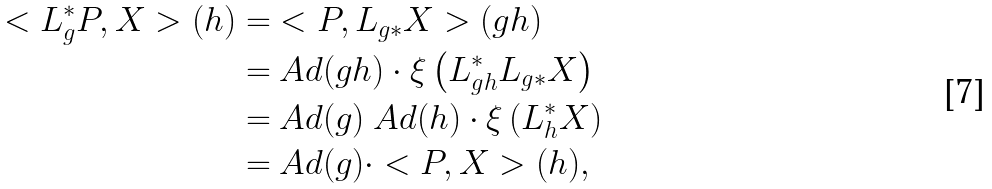Convert formula to latex. <formula><loc_0><loc_0><loc_500><loc_500>< L _ { g } ^ { * } P , X > ( h ) = & < P , L _ { g * } X > ( g h ) \\ = & \ A d ( g h ) \cdot \xi \left ( L _ { g h } ^ { * } L _ { g * } X \right ) \\ = & \ A d ( g ) \ A d ( h ) \cdot \xi \left ( L _ { h } ^ { * } X \right ) \\ = & \ A d ( g ) \cdot < P , X > ( h ) ,</formula> 